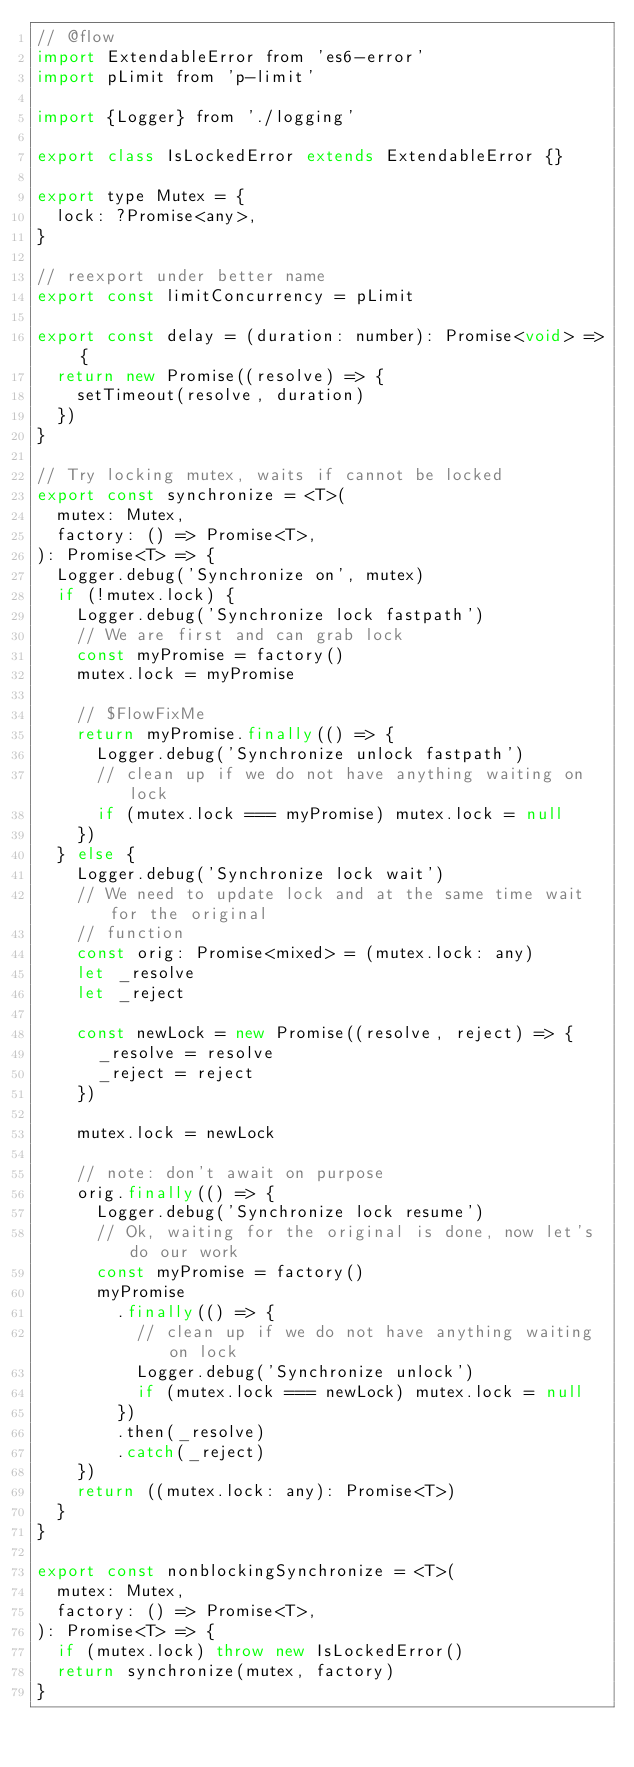<code> <loc_0><loc_0><loc_500><loc_500><_JavaScript_>// @flow
import ExtendableError from 'es6-error'
import pLimit from 'p-limit'

import {Logger} from './logging'

export class IsLockedError extends ExtendableError {}

export type Mutex = {
  lock: ?Promise<any>,
}

// reexport under better name
export const limitConcurrency = pLimit

export const delay = (duration: number): Promise<void> => {
  return new Promise((resolve) => {
    setTimeout(resolve, duration)
  })
}

// Try locking mutex, waits if cannot be locked
export const synchronize = <T>(
  mutex: Mutex,
  factory: () => Promise<T>,
): Promise<T> => {
  Logger.debug('Synchronize on', mutex)
  if (!mutex.lock) {
    Logger.debug('Synchronize lock fastpath')
    // We are first and can grab lock
    const myPromise = factory()
    mutex.lock = myPromise

    // $FlowFixMe
    return myPromise.finally(() => {
      Logger.debug('Synchronize unlock fastpath')
      // clean up if we do not have anything waiting on lock
      if (mutex.lock === myPromise) mutex.lock = null
    })
  } else {
    Logger.debug('Synchronize lock wait')
    // We need to update lock and at the same time wait for the original
    // function
    const orig: Promise<mixed> = (mutex.lock: any)
    let _resolve
    let _reject

    const newLock = new Promise((resolve, reject) => {
      _resolve = resolve
      _reject = reject
    })

    mutex.lock = newLock

    // note: don't await on purpose
    orig.finally(() => {
      Logger.debug('Synchronize lock resume')
      // Ok, waiting for the original is done, now let's do our work
      const myPromise = factory()
      myPromise
        .finally(() => {
          // clean up if we do not have anything waiting on lock
          Logger.debug('Synchronize unlock')
          if (mutex.lock === newLock) mutex.lock = null
        })
        .then(_resolve)
        .catch(_reject)
    })
    return ((mutex.lock: any): Promise<T>)
  }
}

export const nonblockingSynchronize = <T>(
  mutex: Mutex,
  factory: () => Promise<T>,
): Promise<T> => {
  if (mutex.lock) throw new IsLockedError()
  return synchronize(mutex, factory)
}
</code> 